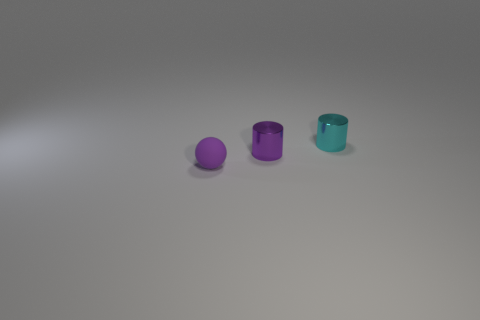Add 1 small gray rubber spheres. How many objects exist? 4 Subtract all cylinders. How many objects are left? 1 Add 1 small metallic cylinders. How many small metallic cylinders exist? 3 Subtract 1 cyan cylinders. How many objects are left? 2 Subtract all purple cylinders. Subtract all cyan things. How many objects are left? 1 Add 3 small metallic cylinders. How many small metallic cylinders are left? 5 